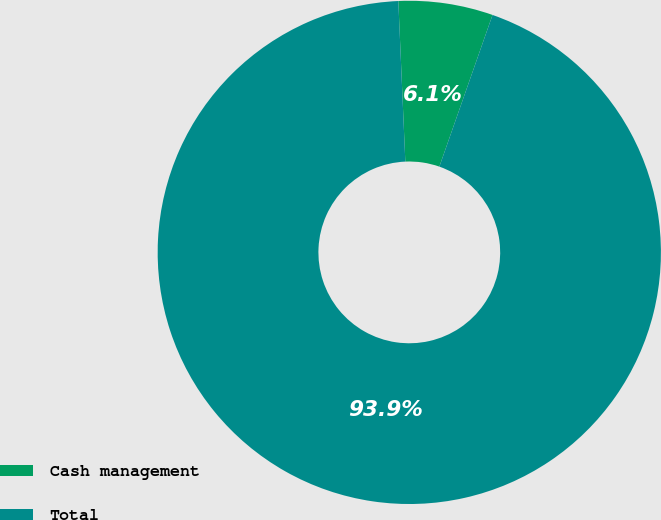<chart> <loc_0><loc_0><loc_500><loc_500><pie_chart><fcel>Cash management<fcel>Total<nl><fcel>6.06%<fcel>93.94%<nl></chart> 